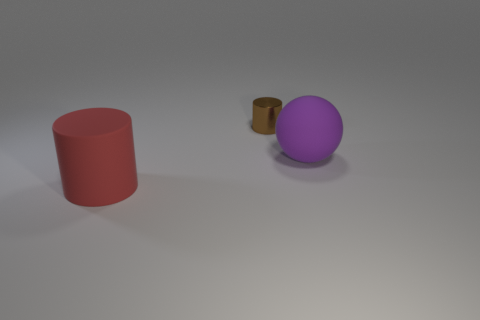There is a purple object that is the same material as the large red object; what is its size?
Offer a terse response. Large. There is a cylinder behind the large thing behind the big matte object that is left of the small metallic thing; what size is it?
Ensure brevity in your answer.  Small. There is a big object that is behind the matte cylinder; what is its color?
Keep it short and to the point. Purple. Are there more matte objects that are to the left of the big rubber ball than large shiny blocks?
Give a very brief answer. Yes. Does the big thing left of the brown metal cylinder have the same shape as the purple matte thing?
Ensure brevity in your answer.  No. How many blue objects are matte cylinders or tiny shiny things?
Keep it short and to the point. 0. Are there more rubber things than purple things?
Your response must be concise. Yes. There is a rubber object that is the same size as the purple matte sphere; what color is it?
Provide a succinct answer. Red. What number of cylinders are small things or tiny gray things?
Give a very brief answer. 1. There is a large red rubber thing; is it the same shape as the object behind the purple rubber thing?
Make the answer very short. Yes. 